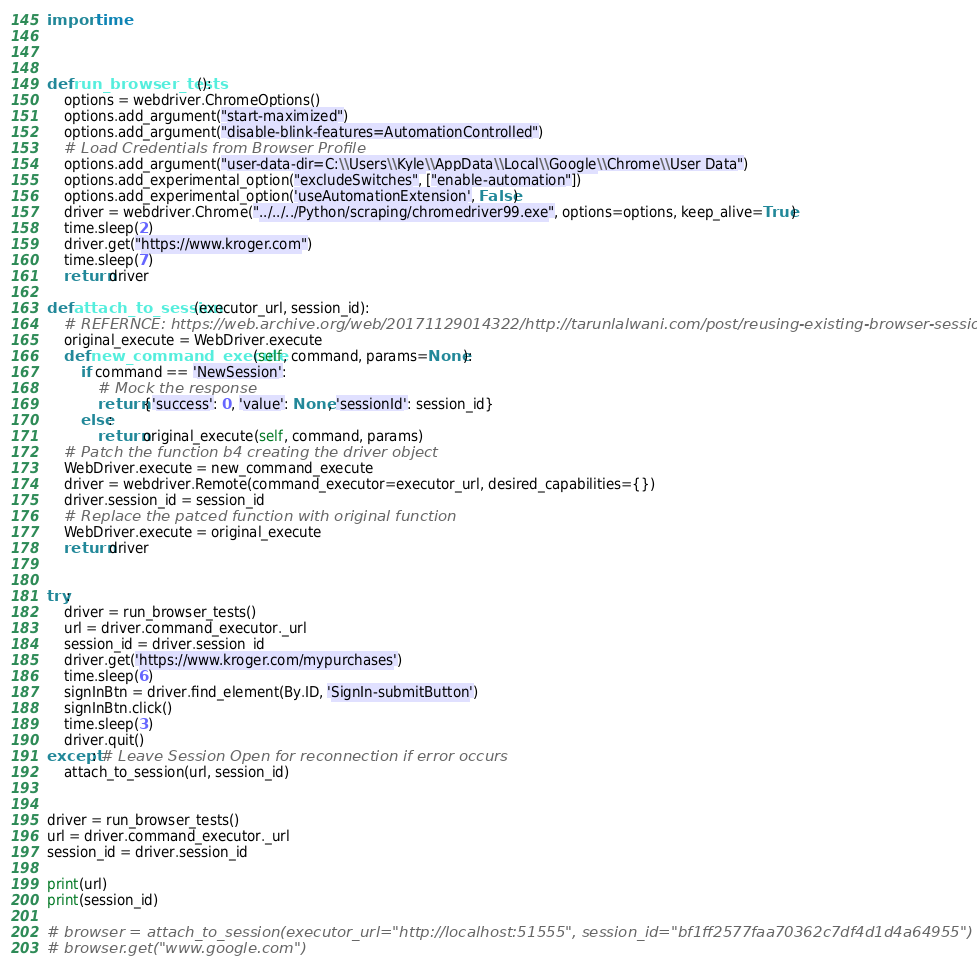Convert code to text. <code><loc_0><loc_0><loc_500><loc_500><_Python_>import time



def run_browser_tests():
    options = webdriver.ChromeOptions() 
    options.add_argument("start-maximized")
    options.add_argument("disable-blink-features=AutomationControlled")
    # Load Credentials from Browser Profile
    options.add_argument("user-data-dir=C:\\Users\\Kyle\\AppData\\Local\\Google\\Chrome\\User Data")
    options.add_experimental_option("excludeSwitches", ["enable-automation"])
    options.add_experimental_option('useAutomationExtension', False)
    driver = webdriver.Chrome("../../../Python/scraping/chromedriver99.exe", options=options, keep_alive=True)
    time.sleep(2)
    driver.get("https://www.kroger.com")
    time.sleep(7)
    return driver

def attach_to_session(executor_url, session_id):
    # REFERNCE: https://web.archive.org/web/20171129014322/http://tarunlalwani.com/post/reusing-existing-browser-session-selenium/
    original_execute = WebDriver.execute
    def new_command_execute(self, command, params=None):
        if command == 'NewSession':
            # Mock the response
            return {'success': 0, 'value': None, 'sessionId': session_id}
        else:
            return original_execute(self, command, params)
    # Patch the function b4 creating the driver object
    WebDriver.execute = new_command_execute
    driver = webdriver.Remote(command_executor=executor_url, desired_capabilities={})
    driver.session_id = session_id
    # Replace the patced function with original function
    WebDriver.execute = original_execute
    return driver


try:
    driver = run_browser_tests()
    url = driver.command_executor._url
    session_id = driver.session_id
    driver.get('https://www.kroger.com/mypurchases') 
    time.sleep(6)
    signInBtn = driver.find_element(By.ID, 'SignIn-submitButton')
    signInBtn.click()
    time.sleep(3)
    driver.quit()
except: # Leave Session Open for reconnection if error occurs
    attach_to_session(url, session_id)


driver = run_browser_tests()
url = driver.command_executor._url
session_id = driver.session_id

print(url)
print(session_id)

# browser = attach_to_session(executor_url="http://localhost:51555", session_id="bf1ff2577faa70362c7df4d1d4a64955")
# browser.get("www.google.com")</code> 